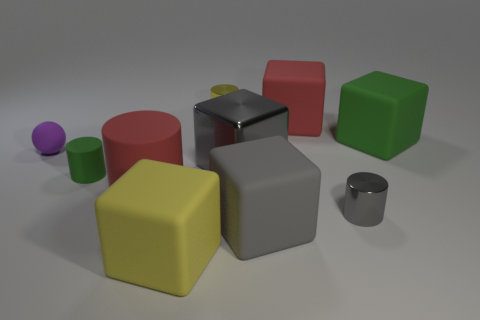There is a large red thing that is right of the yellow rubber object; is it the same shape as the yellow rubber thing?
Offer a very short reply. Yes. How big is the green thing that is in front of the big rubber thing that is on the right side of the big red cube?
Your response must be concise. Small. How many things are big matte objects to the right of the tiny gray metallic thing or objects in front of the large red matte block?
Ensure brevity in your answer.  8. Are there fewer purple rubber objects than big purple rubber cylinders?
Offer a terse response. No. How many objects are small blue cubes or matte cylinders?
Your answer should be compact. 2. Does the large metal thing have the same shape as the large gray matte object?
Give a very brief answer. Yes. Do the gray object that is in front of the small gray object and the green object that is to the left of the gray shiny cylinder have the same size?
Your answer should be compact. No. There is a tiny object that is both to the left of the gray matte object and in front of the purple matte object; what material is it?
Your answer should be very brief. Rubber. Are there any other things that are the same color as the small sphere?
Provide a succinct answer. No. Is the number of things in front of the rubber ball less than the number of tiny yellow blocks?
Offer a very short reply. No. 